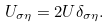Convert formula to latex. <formula><loc_0><loc_0><loc_500><loc_500>U _ { \sigma \eta } = 2 U \delta _ { \sigma \eta } .</formula> 